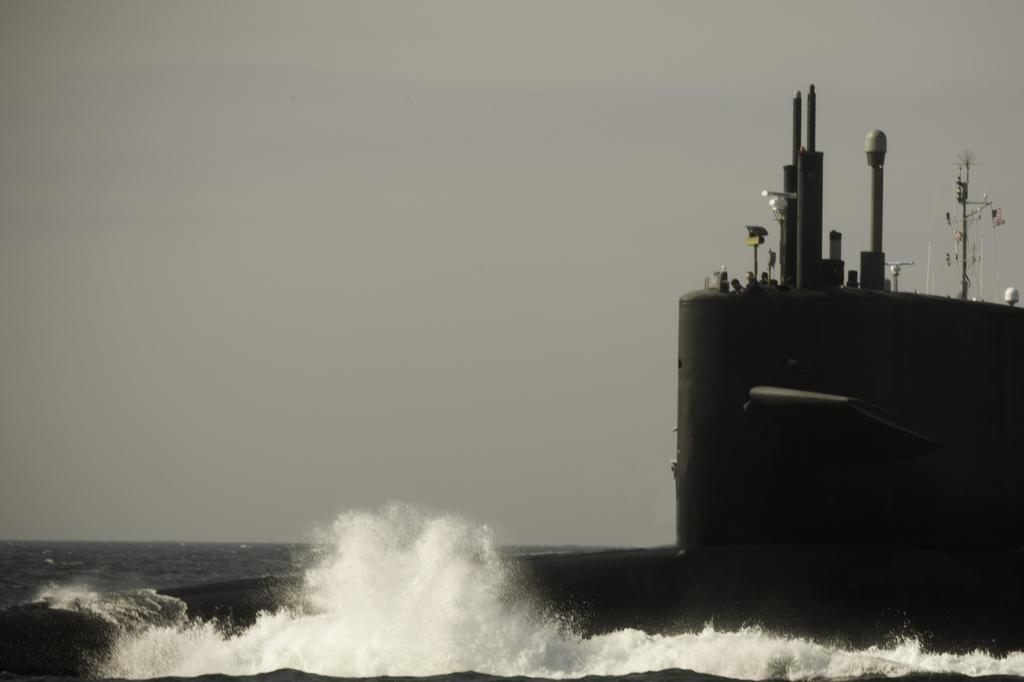What is present at the bottom of the image? There is water at the bottom of the image. What can be seen on the right side of the image? There is a ship on the right side of the image. What is visible at the top of the image? The sky is visible at the top of the image. Where is the cave located in the image? There is no cave present in the image. What type of drink is being served in the hourglass in the image? There is no hourglass or drink present in the image. 